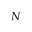Convert formula to latex. <formula><loc_0><loc_0><loc_500><loc_500>N</formula> 